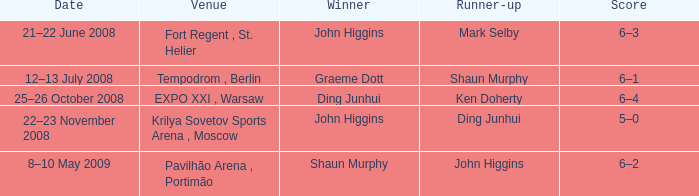In the contest featuring john higgins as the second-best player, who claimed the winning title? Shaun Murphy. 